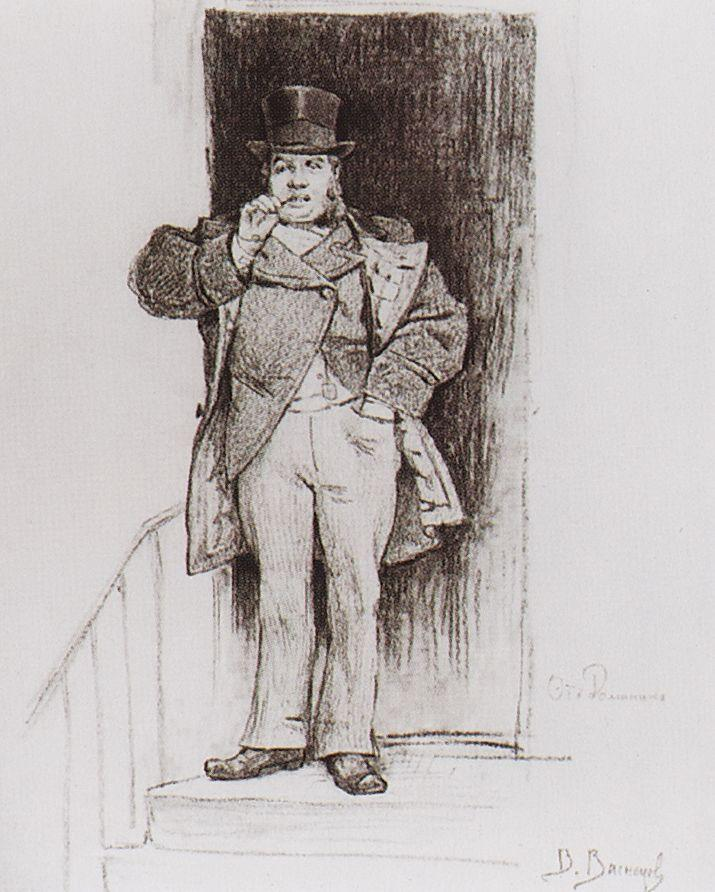Analyze the image in a comprehensive and detailed manner. The image is a black and white sketch depicting a middle-aged man standing in a doorway. He is dressed in a style reminiscent of the late 19th century with a top hat, an elegantly tailored coat, and a scarf. His right hand rests on a cane, suggesting a sense of stature and perhaps a nod to the fashion of his time. He stands with a relaxed posture, his left hand adjusting his scarf, which along with his slight smile, contributes to a friendly yet dignified demeanor. The drawing is executed with fine lines that highlight the detailed texture of his coat and the smoothness of his hat, showcasing the artist's skill in capturing textures and expressions. The signature 'D. Baroung' in the lower right corner suggests the artist's pride in this work. This image could represent a character from a historical narrative or convey themes of elegance and composure during a bygone era. 